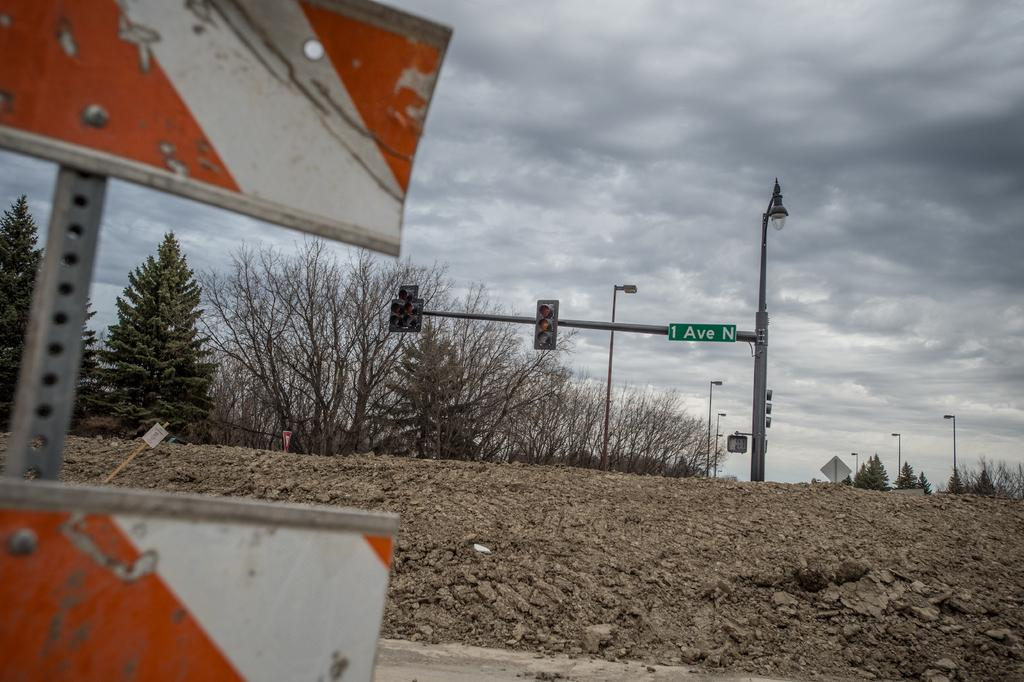<image>
Render a clear and concise summary of the photo. A stop light with the sign 1 Ave N attached to the top right shown on a hazy day. 